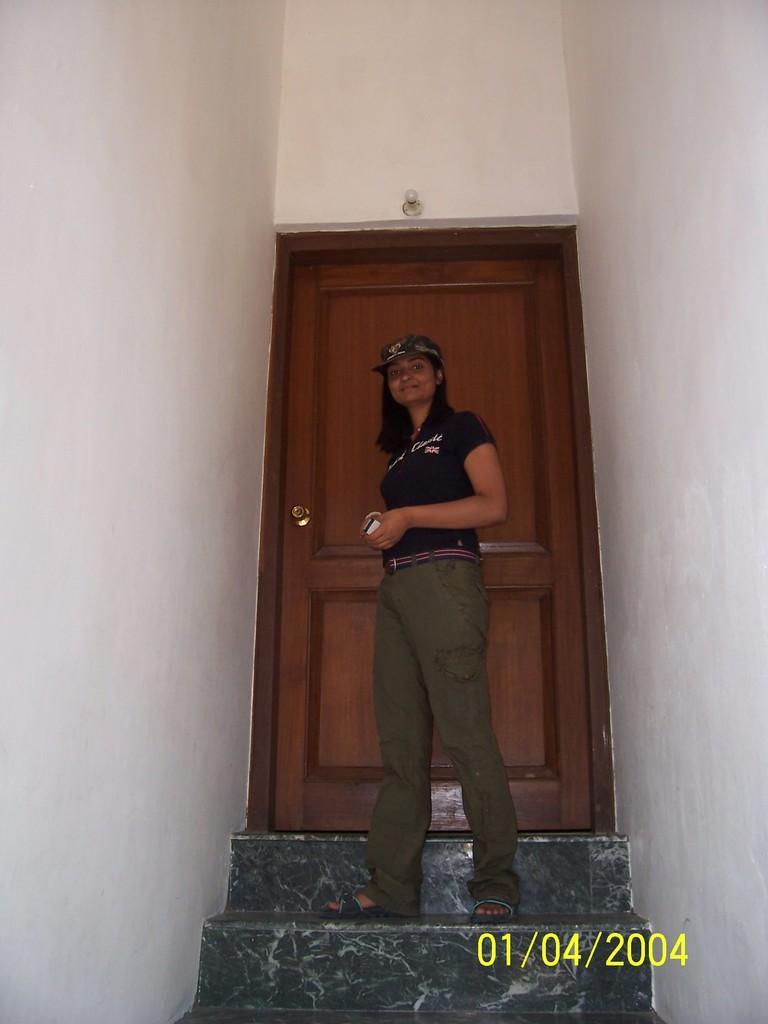Can you describe this image briefly? This image is taken indoors. In the middle of the image a woman is standing on the stairs. In the background there are a few walls and there is a door. 